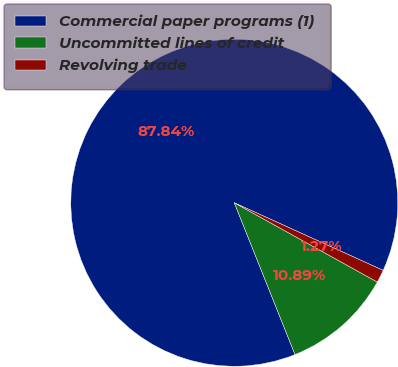<chart> <loc_0><loc_0><loc_500><loc_500><pie_chart><fcel>Commercial paper programs (1)<fcel>Uncommitted lines of credit<fcel>Revolving trade<nl><fcel>87.84%<fcel>10.89%<fcel>1.27%<nl></chart> 